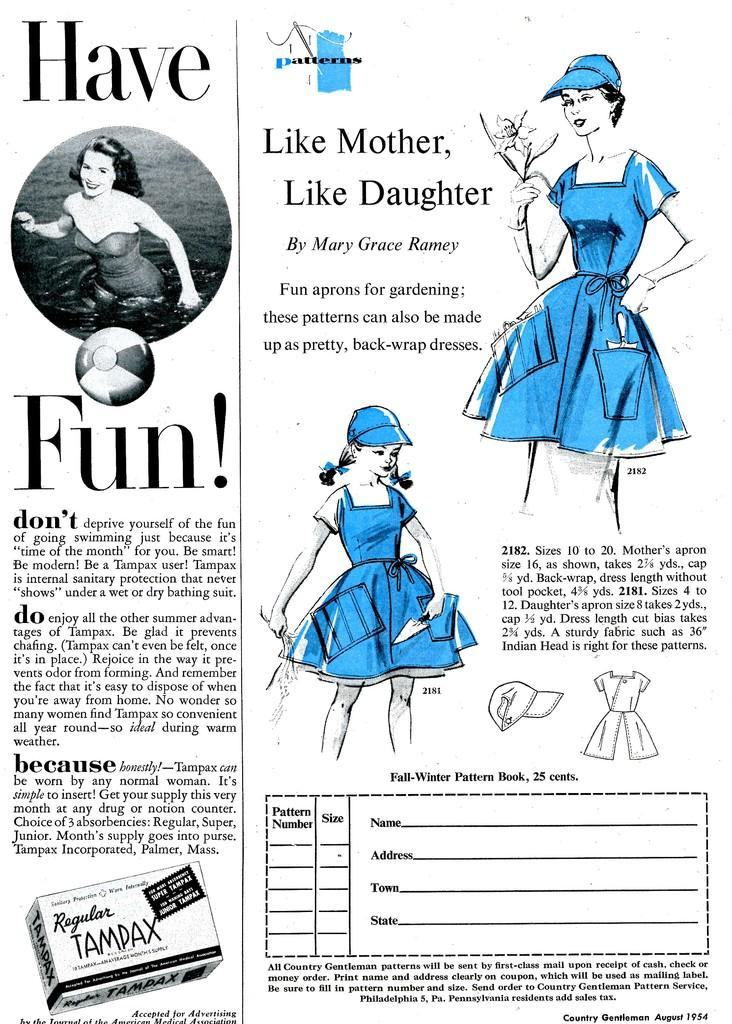What is featured on the poster in the image? There is a poster in the image that features a picture of a girl and a picture of a woman. What else can be seen on the poster besides the images? There is text on the poster. What type of frame is around the poster in the image? There is no frame visible around the poster in the image. What topics are being discussed by the girl and woman in the image? There is no discussion taking place in the image; it only features a poster with images and text. 